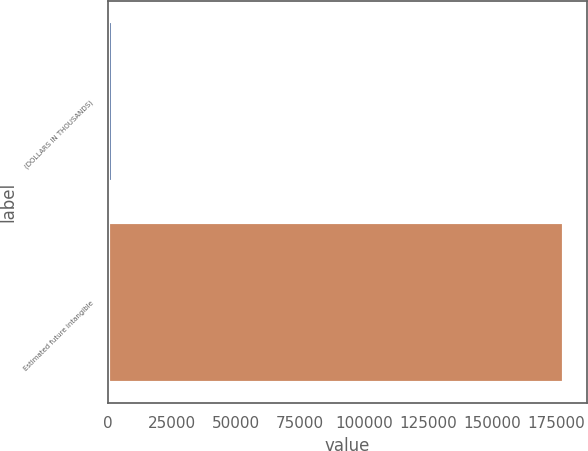Convert chart to OTSL. <chart><loc_0><loc_0><loc_500><loc_500><bar_chart><fcel>(DOLLARS IN THOUSANDS)<fcel>Estimated future intangible<nl><fcel>2023<fcel>178137<nl></chart> 